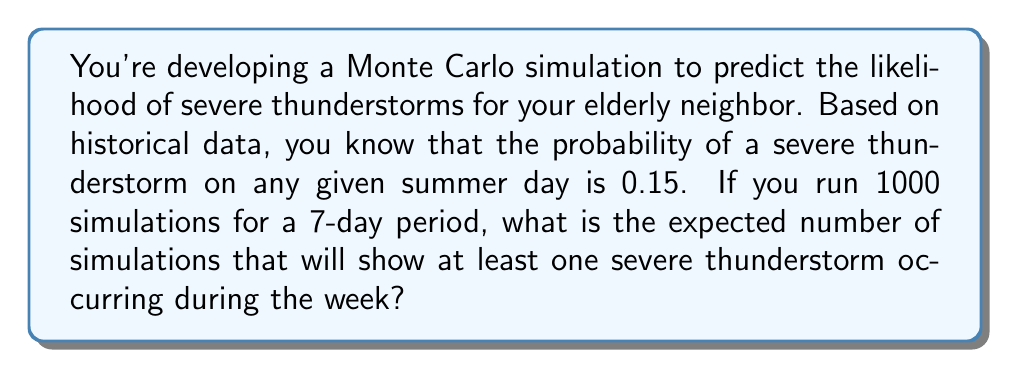Give your solution to this math problem. Let's approach this step-by-step:

1) First, we need to calculate the probability of at least one severe thunderstorm occurring in a 7-day period.

2) The probability of no severe thunderstorm on a given day is $1 - 0.15 = 0.85$.

3) For no severe thunderstorms to occur in 7 days, we need this to happen 7 times in a row. The probability of this is:

   $$(0.85)^7 \approx 0.3206$$

4) Therefore, the probability of at least one severe thunderstorm in 7 days is:

   $$1 - (0.85)^7 \approx 1 - 0.3206 = 0.6794$$

5) In a Monte Carlo simulation, the expected number of successes (in this case, simulations showing at least one severe thunderstorm) is equal to the number of trials multiplied by the probability of success.

6) With 1000 simulations, the expected number is:

   $$1000 * 0.6794 = 679.4$$

7) Since we can't have a fractional number of simulations, we round to the nearest whole number.
Answer: 679 